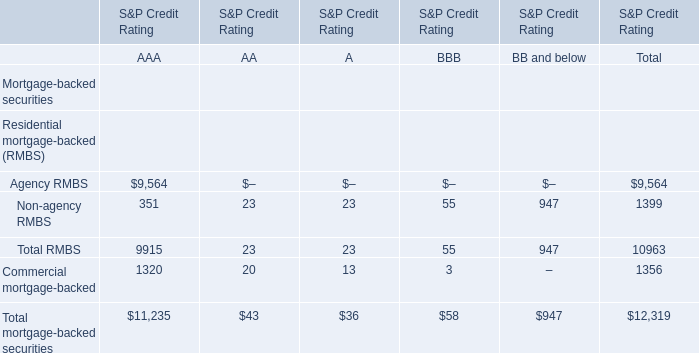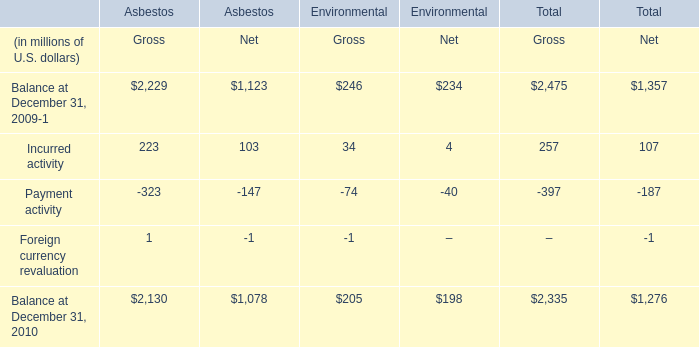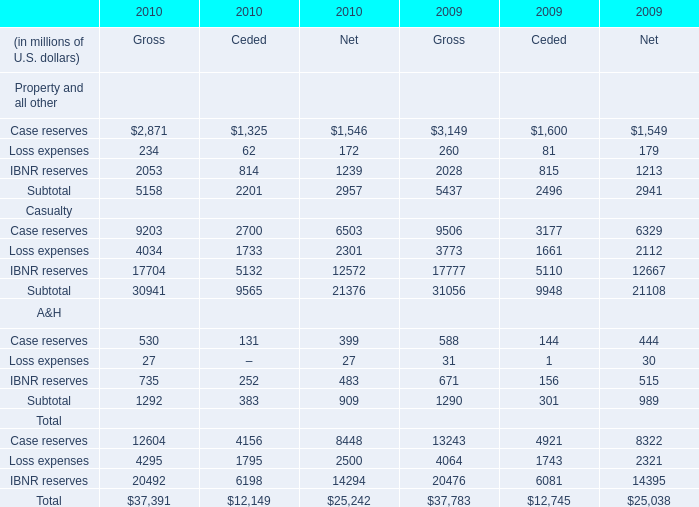"What was the total amount net of property, casualty, and A&H in 2010 ?" (in million) 
Computations: ((2957 + 21376) + 909)
Answer: 25242.0. 